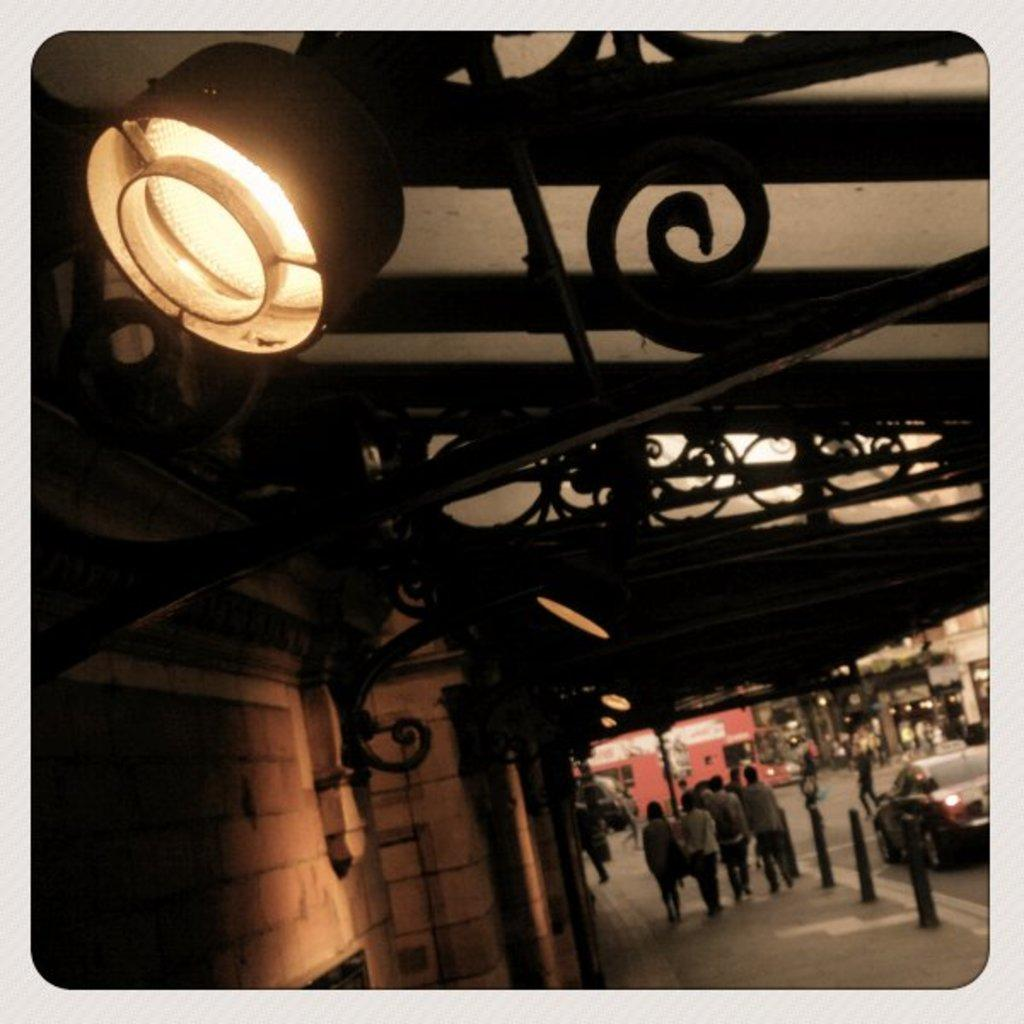What can be seen at the top of the image? There are light and rods at the top of the image. Who or what is present in the image? There are people in the image. What type of structure is visible in the image? There is a wall in the image. What other objects can be seen in the image? There are poles in the image. What is happening on the road in the image? There is a car on the road in the image. Can you describe the background of the image? The background of the image is not clear. What type of apparel is the machine wearing in the image? There is no machine present in the image, and therefore no apparel can be associated with it. Can you describe how the people in the image are touching the wall? The image does not show the people touching the wall, so it is not possible to describe their actions in that regard. 